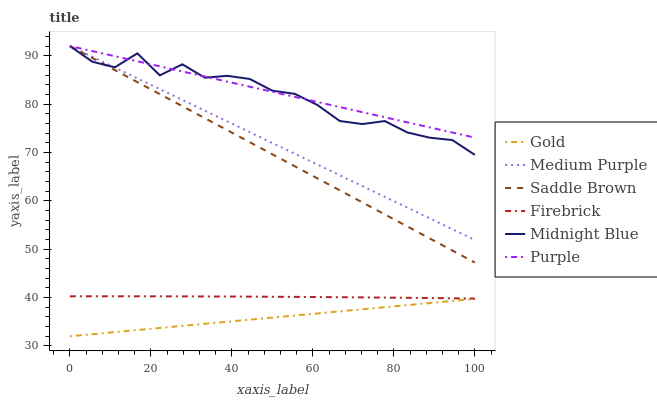Does Gold have the minimum area under the curve?
Answer yes or no. Yes. Does Purple have the maximum area under the curve?
Answer yes or no. Yes. Does Purple have the minimum area under the curve?
Answer yes or no. No. Does Gold have the maximum area under the curve?
Answer yes or no. No. Is Gold the smoothest?
Answer yes or no. Yes. Is Midnight Blue the roughest?
Answer yes or no. Yes. Is Purple the smoothest?
Answer yes or no. No. Is Purple the roughest?
Answer yes or no. No. Does Gold have the lowest value?
Answer yes or no. Yes. Does Purple have the lowest value?
Answer yes or no. No. Does Saddle Brown have the highest value?
Answer yes or no. Yes. Does Gold have the highest value?
Answer yes or no. No. Is Gold less than Medium Purple?
Answer yes or no. Yes. Is Midnight Blue greater than Firebrick?
Answer yes or no. Yes. Does Medium Purple intersect Midnight Blue?
Answer yes or no. Yes. Is Medium Purple less than Midnight Blue?
Answer yes or no. No. Is Medium Purple greater than Midnight Blue?
Answer yes or no. No. Does Gold intersect Medium Purple?
Answer yes or no. No. 